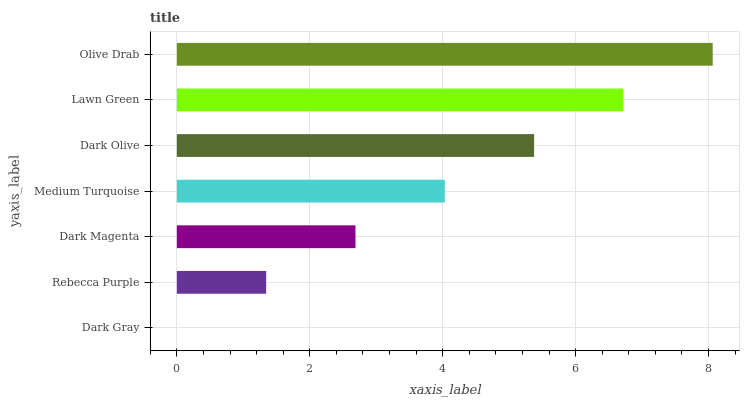Is Dark Gray the minimum?
Answer yes or no. Yes. Is Olive Drab the maximum?
Answer yes or no. Yes. Is Rebecca Purple the minimum?
Answer yes or no. No. Is Rebecca Purple the maximum?
Answer yes or no. No. Is Rebecca Purple greater than Dark Gray?
Answer yes or no. Yes. Is Dark Gray less than Rebecca Purple?
Answer yes or no. Yes. Is Dark Gray greater than Rebecca Purple?
Answer yes or no. No. Is Rebecca Purple less than Dark Gray?
Answer yes or no. No. Is Medium Turquoise the high median?
Answer yes or no. Yes. Is Medium Turquoise the low median?
Answer yes or no. Yes. Is Olive Drab the high median?
Answer yes or no. No. Is Olive Drab the low median?
Answer yes or no. No. 